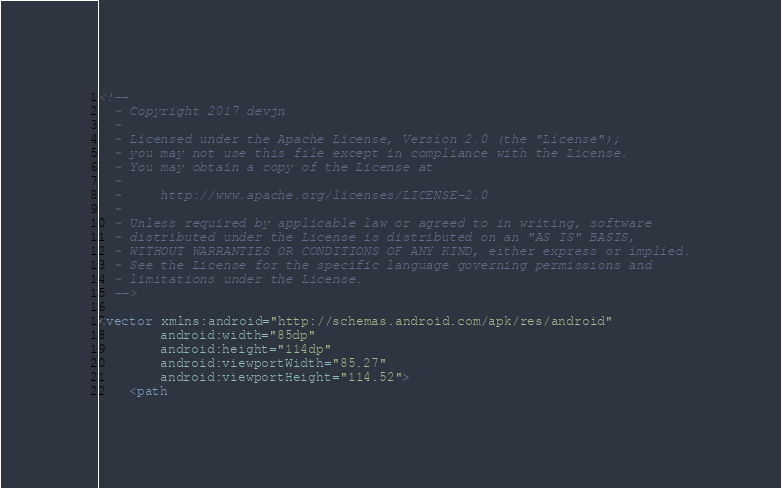<code> <loc_0><loc_0><loc_500><loc_500><_XML_><!--
  ~ Copyright 2017 devjn
  ~
  ~ Licensed under the Apache License, Version 2.0 (the "License");
  ~ you may not use this file except in compliance with the License.
  ~ You may obtain a copy of the License at
  ~
  ~     http://www.apache.org/licenses/LICENSE-2.0
  ~
  ~ Unless required by applicable law or agreed to in writing, software
  ~ distributed under the License is distributed on an "AS IS" BASIS,
  ~ WITHOUT WARRANTIES OR CONDITIONS OF ANY KIND, either express or implied.
  ~ See the License for the specific language governing permissions and
  ~ limitations under the License.
  -->

<vector xmlns:android="http://schemas.android.com/apk/res/android"
        android:width="85dp"
        android:height="114dp"
        android:viewportWidth="85.27"
        android:viewportHeight="114.52">
    <path</code> 